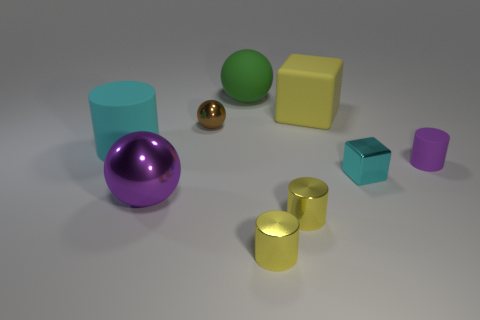Subtract all green spheres. How many yellow cylinders are left? 2 Subtract 2 cylinders. How many cylinders are left? 2 Subtract all purple cylinders. How many cylinders are left? 3 Subtract all small cylinders. How many cylinders are left? 1 Subtract all brown cylinders. Subtract all red blocks. How many cylinders are left? 4 Subtract all spheres. How many objects are left? 6 Add 3 big yellow objects. How many big yellow objects are left? 4 Add 3 tiny balls. How many tiny balls exist? 4 Subtract 0 cyan balls. How many objects are left? 9 Subtract all small cyan objects. Subtract all big blocks. How many objects are left? 7 